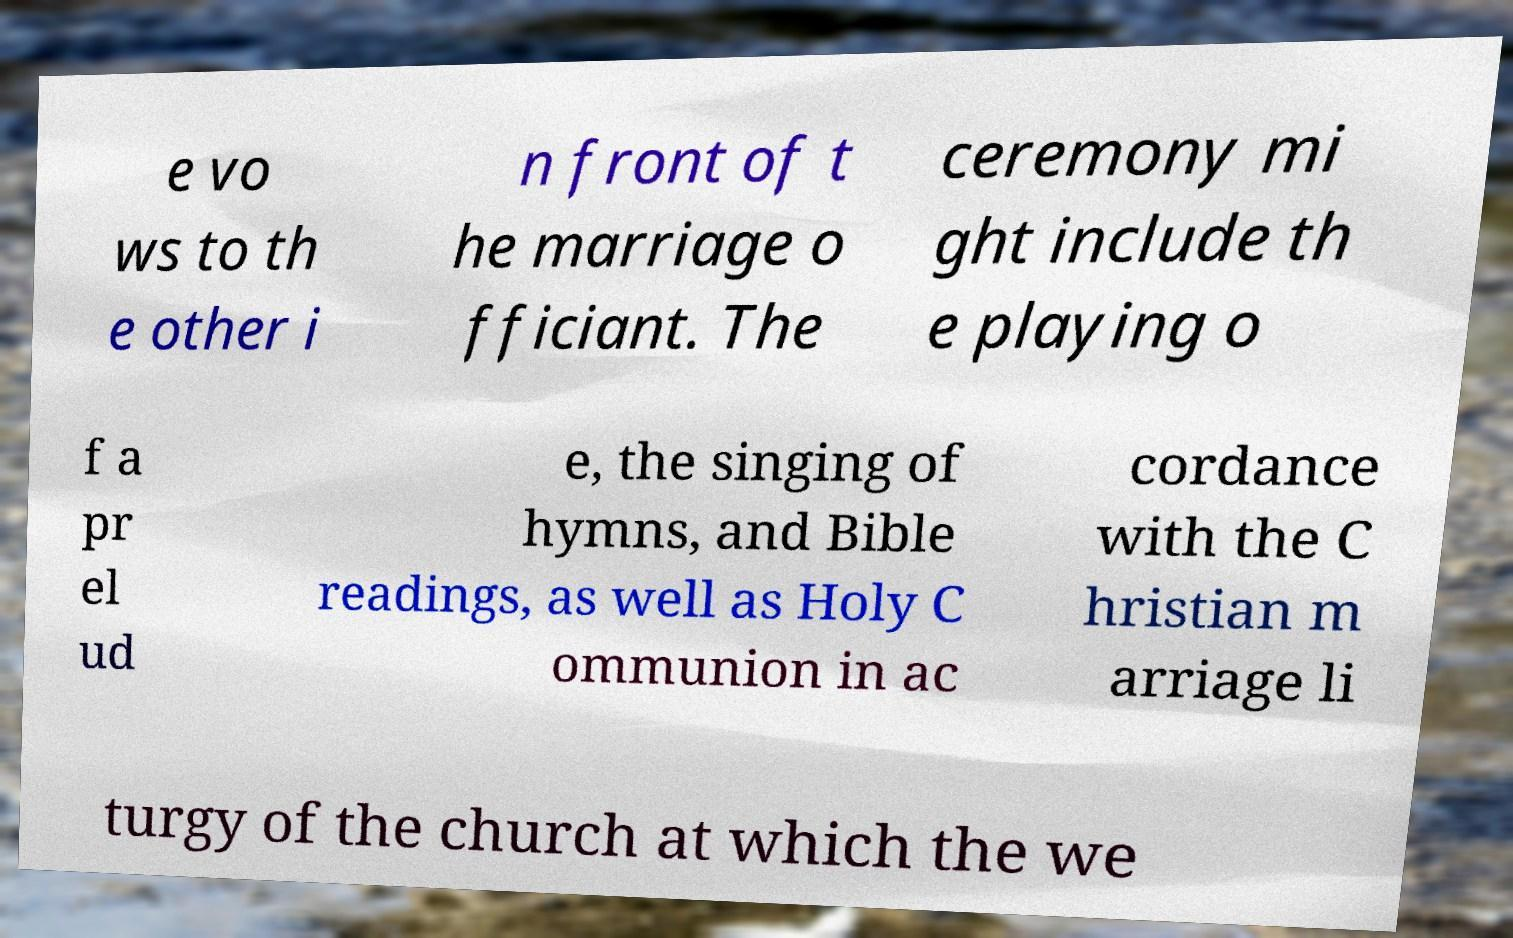For documentation purposes, I need the text within this image transcribed. Could you provide that? e vo ws to th e other i n front of t he marriage o fficiant. The ceremony mi ght include th e playing o f a pr el ud e, the singing of hymns, and Bible readings, as well as Holy C ommunion in ac cordance with the C hristian m arriage li turgy of the church at which the we 